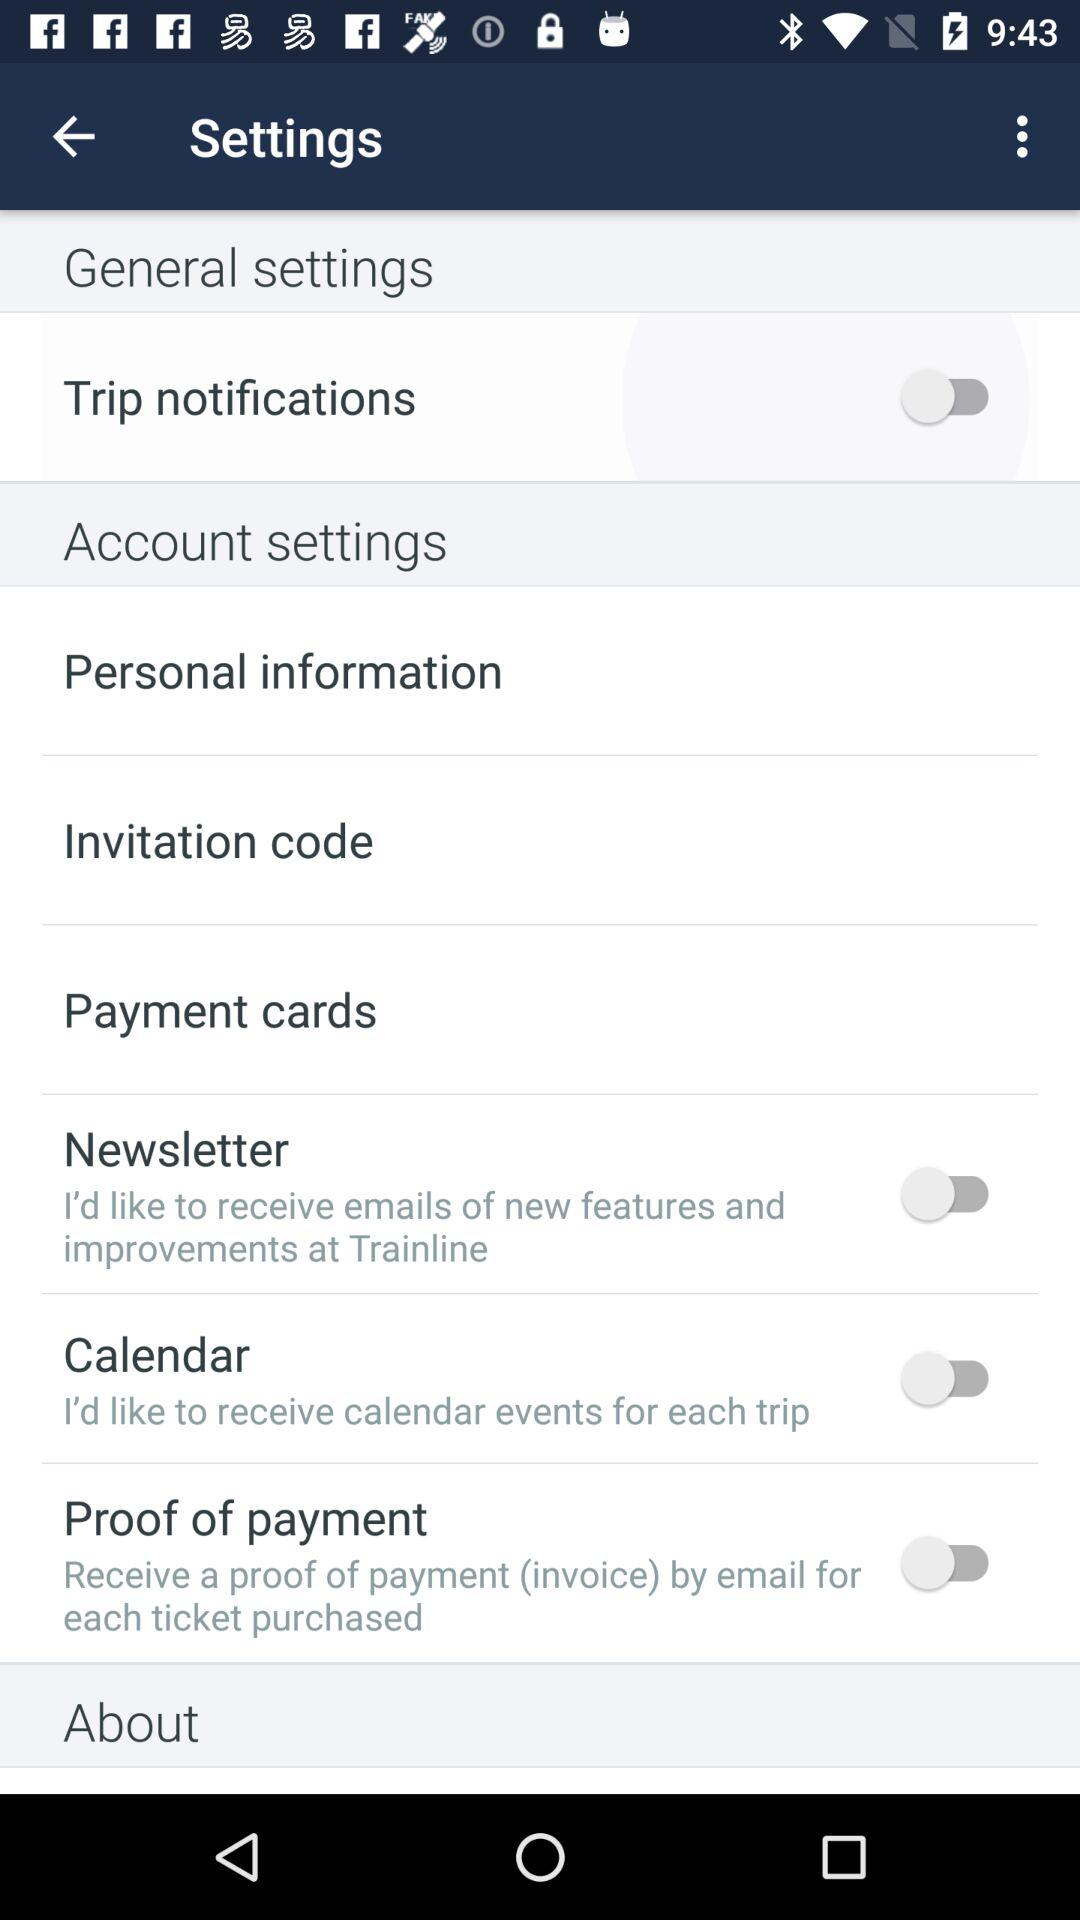Which credit cards are used for payment?
When the provided information is insufficient, respond with <no answer>. <no answer> 